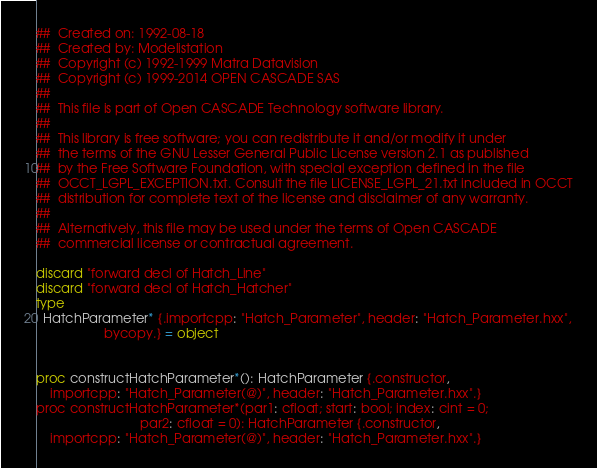Convert code to text. <code><loc_0><loc_0><loc_500><loc_500><_Nim_>##  Created on: 1992-08-18
##  Created by: Modelistation
##  Copyright (c) 1992-1999 Matra Datavision
##  Copyright (c) 1999-2014 OPEN CASCADE SAS
##
##  This file is part of Open CASCADE Technology software library.
##
##  This library is free software; you can redistribute it and/or modify it under
##  the terms of the GNU Lesser General Public License version 2.1 as published
##  by the Free Software Foundation, with special exception defined in the file
##  OCCT_LGPL_EXCEPTION.txt. Consult the file LICENSE_LGPL_21.txt included in OCCT
##  distribution for complete text of the license and disclaimer of any warranty.
##
##  Alternatively, this file may be used under the terms of Open CASCADE
##  commercial license or contractual agreement.

discard "forward decl of Hatch_Line"
discard "forward decl of Hatch_Hatcher"
type
  HatchParameter* {.importcpp: "Hatch_Parameter", header: "Hatch_Parameter.hxx",
                   bycopy.} = object


proc constructHatchParameter*(): HatchParameter {.constructor,
    importcpp: "Hatch_Parameter(@)", header: "Hatch_Parameter.hxx".}
proc constructHatchParameter*(par1: cfloat; start: bool; index: cint = 0;
                             par2: cfloat = 0): HatchParameter {.constructor,
    importcpp: "Hatch_Parameter(@)", header: "Hatch_Parameter.hxx".}

























</code> 